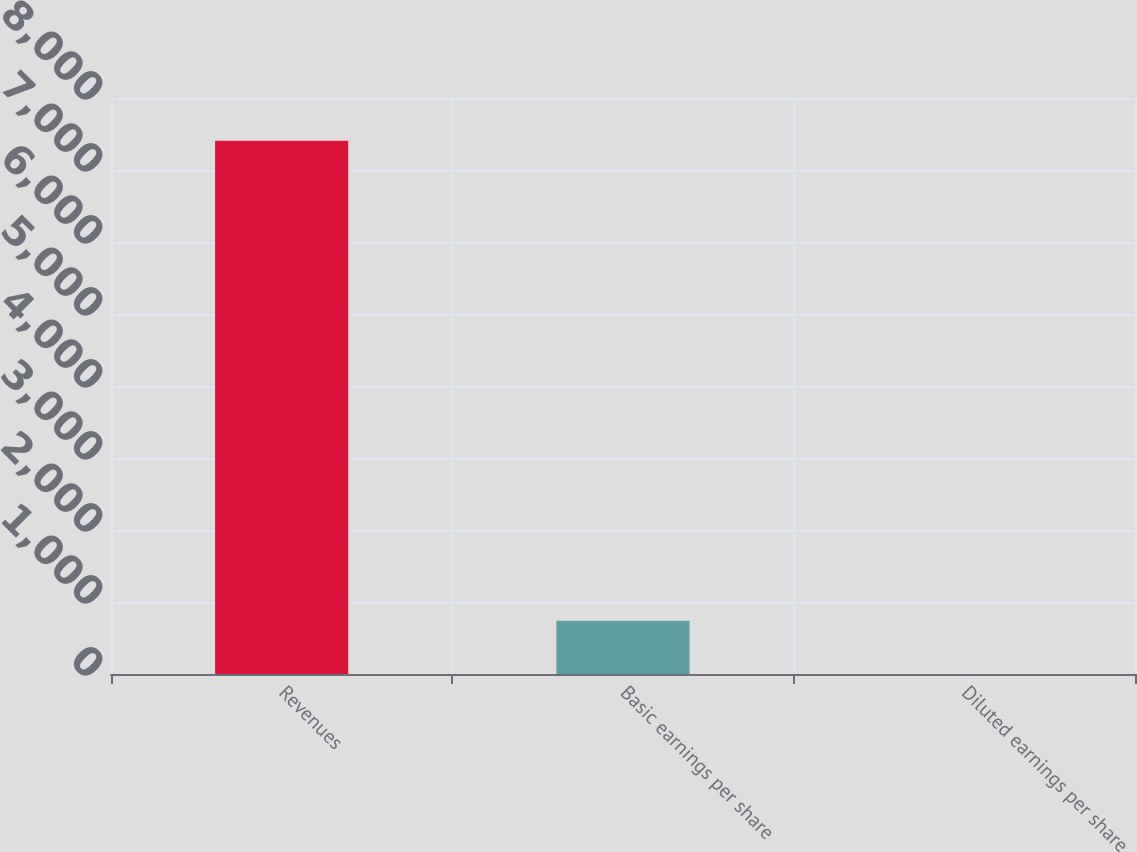Convert chart. <chart><loc_0><loc_0><loc_500><loc_500><bar_chart><fcel>Revenues<fcel>Basic earnings per share<fcel>Diluted earnings per share<nl><fcel>7406<fcel>741.07<fcel>0.52<nl></chart> 